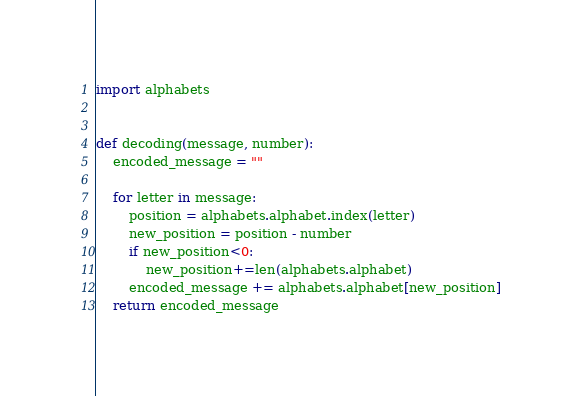Convert code to text. <code><loc_0><loc_0><loc_500><loc_500><_Python_>import alphabets


def decoding(message, number):
    encoded_message = ""

    for letter in message:
        position = alphabets.alphabet.index(letter)
        new_position = position - number
        if new_position<0:
            new_position+=len(alphabets.alphabet)
        encoded_message += alphabets.alphabet[new_position]
    return encoded_message
</code> 